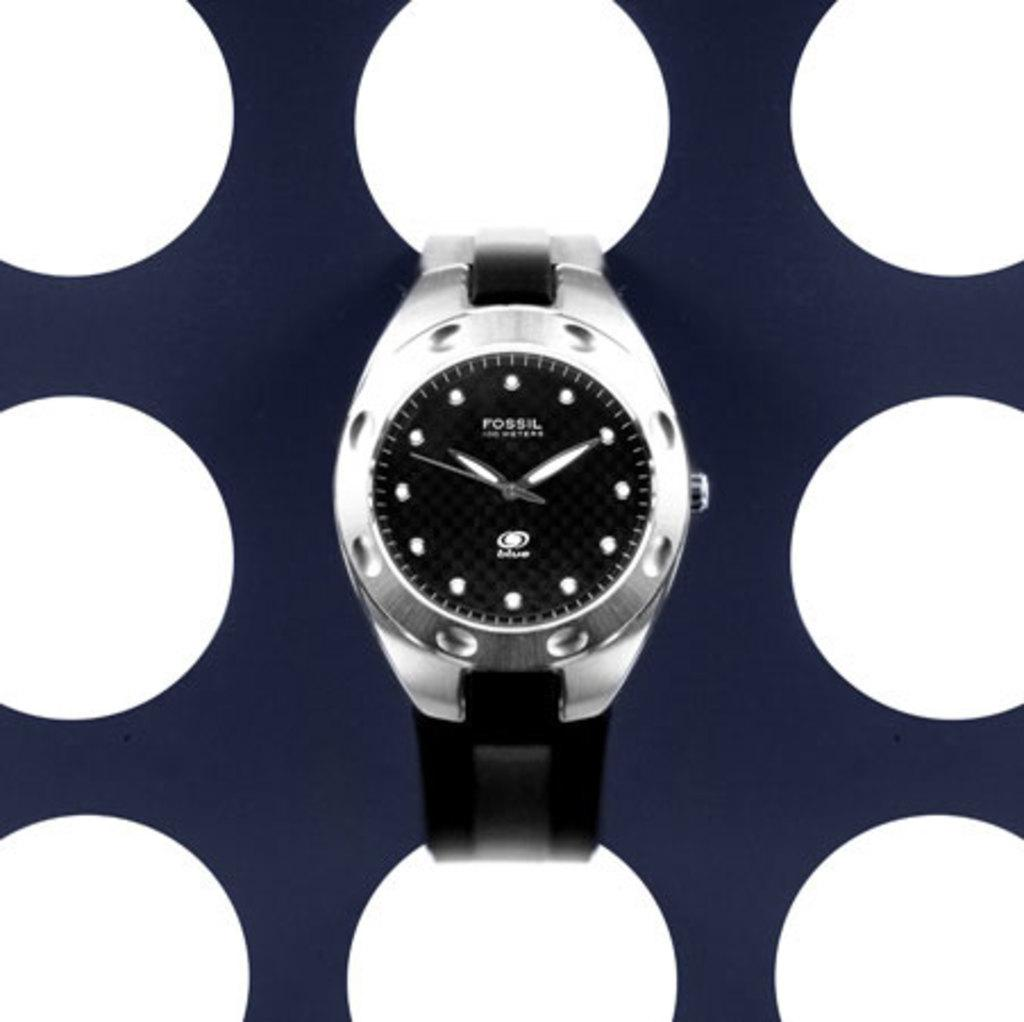<image>
Offer a succinct explanation of the picture presented. A Fossil watch with black bands and a modern style. 